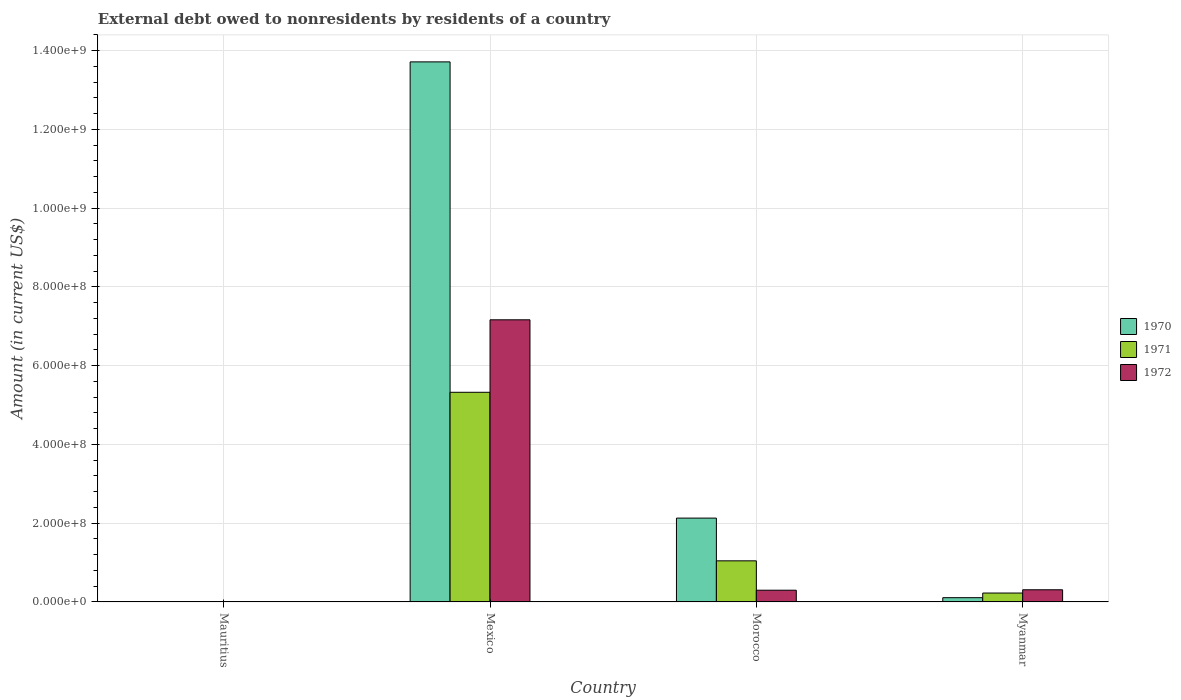Are the number of bars on each tick of the X-axis equal?
Your response must be concise. No. How many bars are there on the 1st tick from the left?
Keep it short and to the point. 1. What is the label of the 4th group of bars from the left?
Make the answer very short. Myanmar. In how many cases, is the number of bars for a given country not equal to the number of legend labels?
Your answer should be very brief. 1. What is the external debt owed by residents in 1972 in Myanmar?
Your answer should be compact. 3.09e+07. Across all countries, what is the maximum external debt owed by residents in 1970?
Your answer should be very brief. 1.37e+09. Across all countries, what is the minimum external debt owed by residents in 1970?
Offer a terse response. 0. In which country was the external debt owed by residents in 1972 maximum?
Your answer should be very brief. Mexico. What is the total external debt owed by residents in 1971 in the graph?
Offer a very short reply. 6.60e+08. What is the difference between the external debt owed by residents in 1970 in Mexico and that in Morocco?
Your answer should be compact. 1.16e+09. What is the difference between the external debt owed by residents in 1970 in Myanmar and the external debt owed by residents in 1972 in Morocco?
Your response must be concise. -1.90e+07. What is the average external debt owed by residents in 1970 per country?
Your response must be concise. 3.99e+08. What is the difference between the external debt owed by residents of/in 1970 and external debt owed by residents of/in 1972 in Mexico?
Provide a short and direct response. 6.55e+08. What is the ratio of the external debt owed by residents in 1970 in Mexico to that in Morocco?
Your response must be concise. 6.44. What is the difference between the highest and the second highest external debt owed by residents in 1971?
Your response must be concise. 5.10e+08. What is the difference between the highest and the lowest external debt owed by residents in 1971?
Your answer should be compact. 5.32e+08. Are all the bars in the graph horizontal?
Provide a short and direct response. No. How many countries are there in the graph?
Give a very brief answer. 4. What is the difference between two consecutive major ticks on the Y-axis?
Make the answer very short. 2.00e+08. Does the graph contain grids?
Make the answer very short. Yes. Where does the legend appear in the graph?
Your answer should be very brief. Center right. How many legend labels are there?
Offer a terse response. 3. How are the legend labels stacked?
Your answer should be compact. Vertical. What is the title of the graph?
Give a very brief answer. External debt owed to nonresidents by residents of a country. What is the label or title of the X-axis?
Make the answer very short. Country. What is the label or title of the Y-axis?
Your answer should be very brief. Amount (in current US$). What is the Amount (in current US$) in 1970 in Mauritius?
Offer a terse response. 0. What is the Amount (in current US$) of 1971 in Mauritius?
Your response must be concise. 0. What is the Amount (in current US$) of 1972 in Mauritius?
Provide a short and direct response. 1.06e+06. What is the Amount (in current US$) in 1970 in Mexico?
Your response must be concise. 1.37e+09. What is the Amount (in current US$) in 1971 in Mexico?
Make the answer very short. 5.32e+08. What is the Amount (in current US$) of 1972 in Mexico?
Your answer should be compact. 7.17e+08. What is the Amount (in current US$) in 1970 in Morocco?
Make the answer very short. 2.13e+08. What is the Amount (in current US$) in 1971 in Morocco?
Provide a short and direct response. 1.04e+08. What is the Amount (in current US$) in 1972 in Morocco?
Give a very brief answer. 2.98e+07. What is the Amount (in current US$) in 1970 in Myanmar?
Your response must be concise. 1.08e+07. What is the Amount (in current US$) of 1971 in Myanmar?
Provide a short and direct response. 2.26e+07. What is the Amount (in current US$) in 1972 in Myanmar?
Your response must be concise. 3.09e+07. Across all countries, what is the maximum Amount (in current US$) in 1970?
Make the answer very short. 1.37e+09. Across all countries, what is the maximum Amount (in current US$) in 1971?
Offer a very short reply. 5.32e+08. Across all countries, what is the maximum Amount (in current US$) of 1972?
Provide a short and direct response. 7.17e+08. Across all countries, what is the minimum Amount (in current US$) of 1970?
Your answer should be very brief. 0. Across all countries, what is the minimum Amount (in current US$) of 1971?
Offer a very short reply. 0. Across all countries, what is the minimum Amount (in current US$) in 1972?
Keep it short and to the point. 1.06e+06. What is the total Amount (in current US$) in 1970 in the graph?
Your response must be concise. 1.60e+09. What is the total Amount (in current US$) in 1971 in the graph?
Offer a very short reply. 6.60e+08. What is the total Amount (in current US$) of 1972 in the graph?
Your response must be concise. 7.78e+08. What is the difference between the Amount (in current US$) in 1972 in Mauritius and that in Mexico?
Keep it short and to the point. -7.16e+08. What is the difference between the Amount (in current US$) in 1972 in Mauritius and that in Morocco?
Your answer should be very brief. -2.88e+07. What is the difference between the Amount (in current US$) of 1972 in Mauritius and that in Myanmar?
Provide a short and direct response. -2.99e+07. What is the difference between the Amount (in current US$) of 1970 in Mexico and that in Morocco?
Your response must be concise. 1.16e+09. What is the difference between the Amount (in current US$) of 1971 in Mexico and that in Morocco?
Keep it short and to the point. 4.28e+08. What is the difference between the Amount (in current US$) of 1972 in Mexico and that in Morocco?
Provide a short and direct response. 6.87e+08. What is the difference between the Amount (in current US$) of 1970 in Mexico and that in Myanmar?
Your answer should be very brief. 1.36e+09. What is the difference between the Amount (in current US$) in 1971 in Mexico and that in Myanmar?
Offer a very short reply. 5.10e+08. What is the difference between the Amount (in current US$) of 1972 in Mexico and that in Myanmar?
Provide a short and direct response. 6.86e+08. What is the difference between the Amount (in current US$) in 1970 in Morocco and that in Myanmar?
Give a very brief answer. 2.02e+08. What is the difference between the Amount (in current US$) of 1971 in Morocco and that in Myanmar?
Keep it short and to the point. 8.18e+07. What is the difference between the Amount (in current US$) of 1972 in Morocco and that in Myanmar?
Give a very brief answer. -1.11e+06. What is the difference between the Amount (in current US$) of 1970 in Mexico and the Amount (in current US$) of 1971 in Morocco?
Ensure brevity in your answer.  1.27e+09. What is the difference between the Amount (in current US$) in 1970 in Mexico and the Amount (in current US$) in 1972 in Morocco?
Ensure brevity in your answer.  1.34e+09. What is the difference between the Amount (in current US$) of 1971 in Mexico and the Amount (in current US$) of 1972 in Morocco?
Keep it short and to the point. 5.03e+08. What is the difference between the Amount (in current US$) of 1970 in Mexico and the Amount (in current US$) of 1971 in Myanmar?
Your answer should be compact. 1.35e+09. What is the difference between the Amount (in current US$) of 1970 in Mexico and the Amount (in current US$) of 1972 in Myanmar?
Provide a short and direct response. 1.34e+09. What is the difference between the Amount (in current US$) of 1971 in Mexico and the Amount (in current US$) of 1972 in Myanmar?
Keep it short and to the point. 5.02e+08. What is the difference between the Amount (in current US$) of 1970 in Morocco and the Amount (in current US$) of 1971 in Myanmar?
Your answer should be very brief. 1.90e+08. What is the difference between the Amount (in current US$) of 1970 in Morocco and the Amount (in current US$) of 1972 in Myanmar?
Your answer should be compact. 1.82e+08. What is the difference between the Amount (in current US$) of 1971 in Morocco and the Amount (in current US$) of 1972 in Myanmar?
Keep it short and to the point. 7.35e+07. What is the average Amount (in current US$) of 1970 per country?
Ensure brevity in your answer.  3.99e+08. What is the average Amount (in current US$) of 1971 per country?
Your answer should be very brief. 1.65e+08. What is the average Amount (in current US$) of 1972 per country?
Offer a very short reply. 1.95e+08. What is the difference between the Amount (in current US$) in 1970 and Amount (in current US$) in 1971 in Mexico?
Ensure brevity in your answer.  8.39e+08. What is the difference between the Amount (in current US$) in 1970 and Amount (in current US$) in 1972 in Mexico?
Offer a terse response. 6.55e+08. What is the difference between the Amount (in current US$) of 1971 and Amount (in current US$) of 1972 in Mexico?
Keep it short and to the point. -1.84e+08. What is the difference between the Amount (in current US$) of 1970 and Amount (in current US$) of 1971 in Morocco?
Offer a terse response. 1.09e+08. What is the difference between the Amount (in current US$) of 1970 and Amount (in current US$) of 1972 in Morocco?
Your response must be concise. 1.83e+08. What is the difference between the Amount (in current US$) of 1971 and Amount (in current US$) of 1972 in Morocco?
Provide a short and direct response. 7.46e+07. What is the difference between the Amount (in current US$) in 1970 and Amount (in current US$) in 1971 in Myanmar?
Provide a succinct answer. -1.18e+07. What is the difference between the Amount (in current US$) in 1970 and Amount (in current US$) in 1972 in Myanmar?
Provide a short and direct response. -2.01e+07. What is the difference between the Amount (in current US$) in 1971 and Amount (in current US$) in 1972 in Myanmar?
Give a very brief answer. -8.31e+06. What is the ratio of the Amount (in current US$) of 1972 in Mauritius to that in Mexico?
Your answer should be compact. 0. What is the ratio of the Amount (in current US$) of 1972 in Mauritius to that in Morocco?
Offer a terse response. 0.04. What is the ratio of the Amount (in current US$) in 1972 in Mauritius to that in Myanmar?
Keep it short and to the point. 0.03. What is the ratio of the Amount (in current US$) of 1970 in Mexico to that in Morocco?
Your answer should be compact. 6.44. What is the ratio of the Amount (in current US$) of 1971 in Mexico to that in Morocco?
Offer a very short reply. 5.1. What is the ratio of the Amount (in current US$) in 1972 in Mexico to that in Morocco?
Make the answer very short. 24.03. What is the ratio of the Amount (in current US$) in 1970 in Mexico to that in Myanmar?
Provide a short and direct response. 126.68. What is the ratio of the Amount (in current US$) of 1971 in Mexico to that in Myanmar?
Your answer should be very brief. 23.54. What is the ratio of the Amount (in current US$) of 1972 in Mexico to that in Myanmar?
Keep it short and to the point. 23.17. What is the ratio of the Amount (in current US$) in 1970 in Morocco to that in Myanmar?
Provide a succinct answer. 19.67. What is the ratio of the Amount (in current US$) in 1971 in Morocco to that in Myanmar?
Your response must be concise. 4.62. What is the ratio of the Amount (in current US$) in 1972 in Morocco to that in Myanmar?
Give a very brief answer. 0.96. What is the difference between the highest and the second highest Amount (in current US$) of 1970?
Your response must be concise. 1.16e+09. What is the difference between the highest and the second highest Amount (in current US$) in 1971?
Your answer should be very brief. 4.28e+08. What is the difference between the highest and the second highest Amount (in current US$) in 1972?
Your response must be concise. 6.86e+08. What is the difference between the highest and the lowest Amount (in current US$) in 1970?
Give a very brief answer. 1.37e+09. What is the difference between the highest and the lowest Amount (in current US$) of 1971?
Your answer should be compact. 5.32e+08. What is the difference between the highest and the lowest Amount (in current US$) in 1972?
Provide a short and direct response. 7.16e+08. 